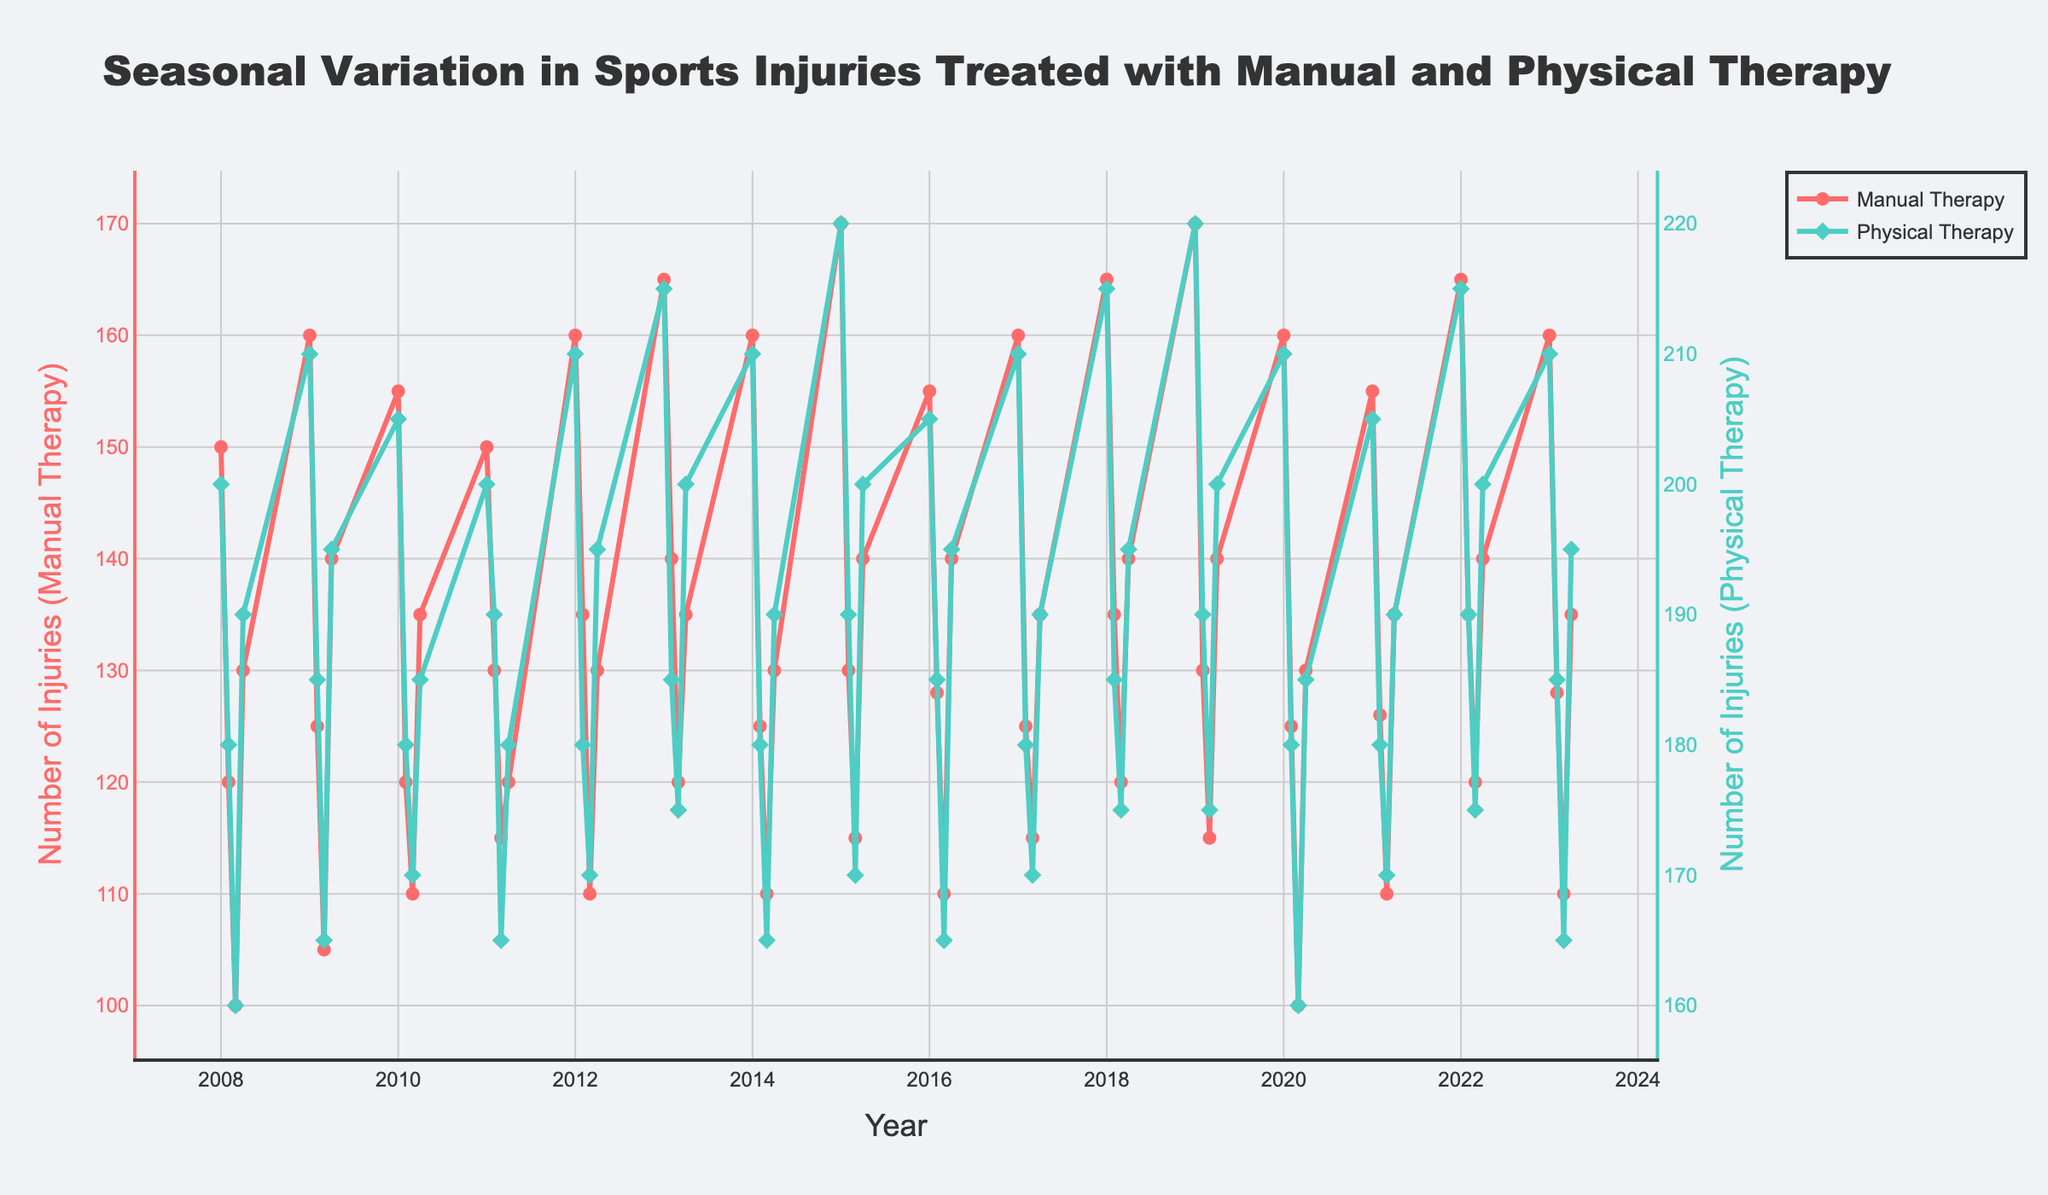What's the title of the plot? Look at the top of the figure. The largest text is the title.
Answer: "Seasonal Variation in Sports Injuries Treated with Manual and Physical Therapy" How are the trends for Manual Therapy and Physical Therapy visually distinguished? Different colors and markers distinguish the trends. The Manual Therapy line is red with circle markers, and the Physical Therapy line is teal with diamond markers.
Answer: By different colors and markers How does the number of injuries treated with manual therapy in Q1 of 2008 compare to Q1 of 2013? From the plot, identify the points corresponding to Q1 2008 and Q1 2013 on the lines representing manual therapy. Comparing these values, Q1 2008 has 150 injuries, and Q1 2013 has 165 injuries.
Answer: Q1 2013 is higher Which therapy has more consistent seasonal variation: Manual or Physical? Consistent variation means similar patterns each quarter year after year. Observing the density and spread of the lines, the Manual Therapy trend is more consistent, with fewer fluctuations over the years.
Answer: Manual Therapy What is the overall trend for both therapies from 2008 to 2023? By observing the start and end points of both trends, there is a slight increase for both therapies, but Physical Therapy shows a more pronounced increase over the years.
Answer: An increasing trend Is there a significant drop in injuries for any therapy in any particular year? Look for a sharp decline in either of the lines. Notably, in 2020 Q3, both therapies show a significant drop in injuries.
Answer: Yes, in 2020 Q3 What is the highest number of injuries treated with manual therapy and in which quarter does it occur? Observe the peak point on the manual therapy line. The highest point is in Q1 of 2019 with 170 injuries.
Answer: 170 in Q1 2019 Compare the seasonal patterns: In which quarter do injuries peak most often for both therapies? Check visually which quarters have the highest points most consistently. Q1 shows the peaks for both therapies quite frequently.
Answer: Q1 By how much did the number of injuries treated with Physical Therapy differ between Q2 2010 and Q2 2020? Locate both points on the Physical Therapy line. In Q2 2010, there were 180 injuries, and in Q2 2020, there were 180 injuries as well. The difference is 180 - 180 = 0.
Answer: 0 What was the trend during the global COVID-19 pandemic period around 2020 for both therapies? Check the line segments for the year 2020. Both lines show a dip in injuries around Q3 of 2020, indicating a decline during this period.
Answer: A decline in 2020 